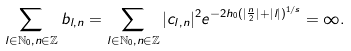Convert formula to latex. <formula><loc_0><loc_0><loc_500><loc_500>\sum _ { l \in \mathbb { N } _ { 0 } , n \in \mathbb { Z } } b _ { l , n } = \sum _ { l \in \mathbb { N } _ { 0 } , n \in \mathbb { Z } } | c _ { l , n } | ^ { 2 } e ^ { - 2 h _ { 0 } ( | \frac { n } { 2 } | + | l | ) ^ { 1 / s } } = \infty .</formula> 